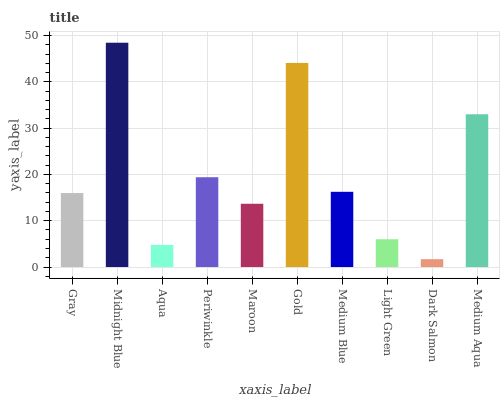Is Midnight Blue the maximum?
Answer yes or no. Yes. Is Aqua the minimum?
Answer yes or no. No. Is Aqua the maximum?
Answer yes or no. No. Is Midnight Blue greater than Aqua?
Answer yes or no. Yes. Is Aqua less than Midnight Blue?
Answer yes or no. Yes. Is Aqua greater than Midnight Blue?
Answer yes or no. No. Is Midnight Blue less than Aqua?
Answer yes or no. No. Is Medium Blue the high median?
Answer yes or no. Yes. Is Gray the low median?
Answer yes or no. Yes. Is Gold the high median?
Answer yes or no. No. Is Light Green the low median?
Answer yes or no. No. 